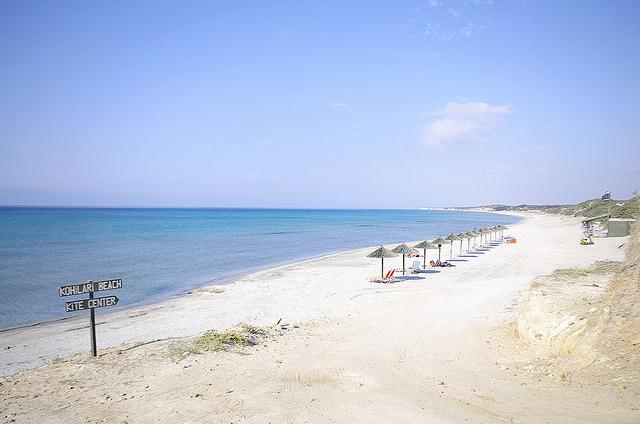What color are the chairs?
Quick response, please. Red. Is it cloudy today?
Answer briefly. No. What number of grains of sand are on the beach?
Answer briefly. 100,000,000. Does this look like a busy beach?
Be succinct. No. Is the beach flat?
Be succinct. Yes. Is the sand on this beach white?
Short answer required. Yes. 